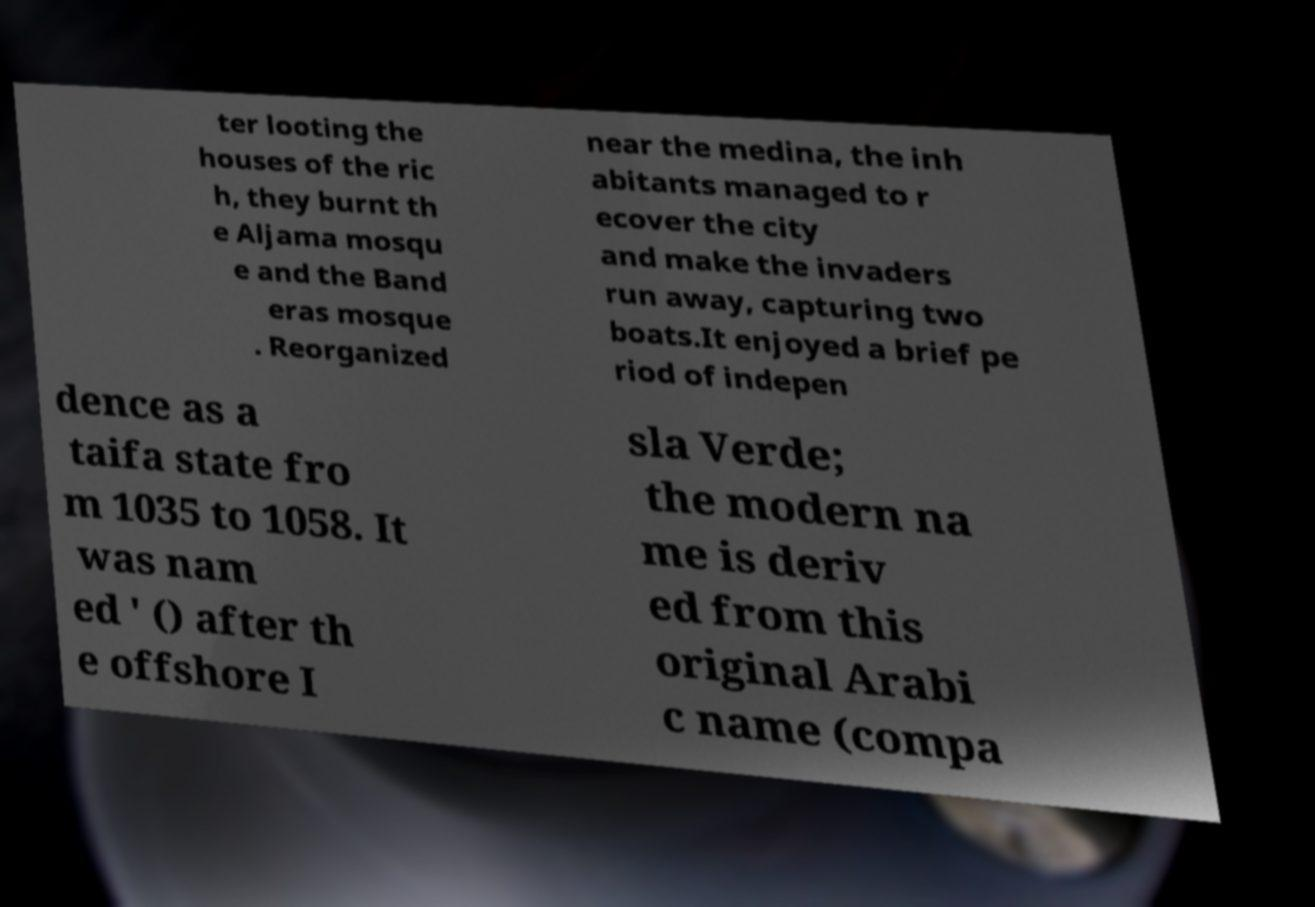Please identify and transcribe the text found in this image. ter looting the houses of the ric h, they burnt th e Aljama mosqu e and the Band eras mosque . Reorganized near the medina, the inh abitants managed to r ecover the city and make the invaders run away, capturing two boats.It enjoyed a brief pe riod of indepen dence as a taifa state fro m 1035 to 1058. It was nam ed ' () after th e offshore I sla Verde; the modern na me is deriv ed from this original Arabi c name (compa 